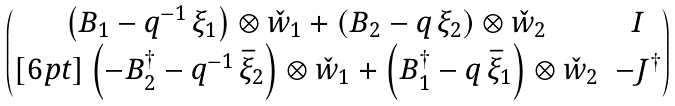Convert formula to latex. <formula><loc_0><loc_0><loc_500><loc_500>\begin{pmatrix} \left ( B _ { 1 } - q ^ { - 1 } \, \xi _ { 1 } \right ) \otimes \check { w } _ { 1 } + \left ( B _ { 2 } - q \, \xi _ { 2 } \right ) \otimes \check { w } _ { 2 } & I \\ [ 6 p t ] \left ( - B _ { 2 } ^ { \dag } - q ^ { - 1 } \, \bar { \xi } _ { 2 } \right ) \otimes \check { w } _ { 1 } + \left ( B _ { 1 } ^ { \dag } - q \, \bar { \xi } _ { 1 } \right ) \otimes \check { w } _ { 2 } & - J ^ { \dag } \end{pmatrix}</formula> 